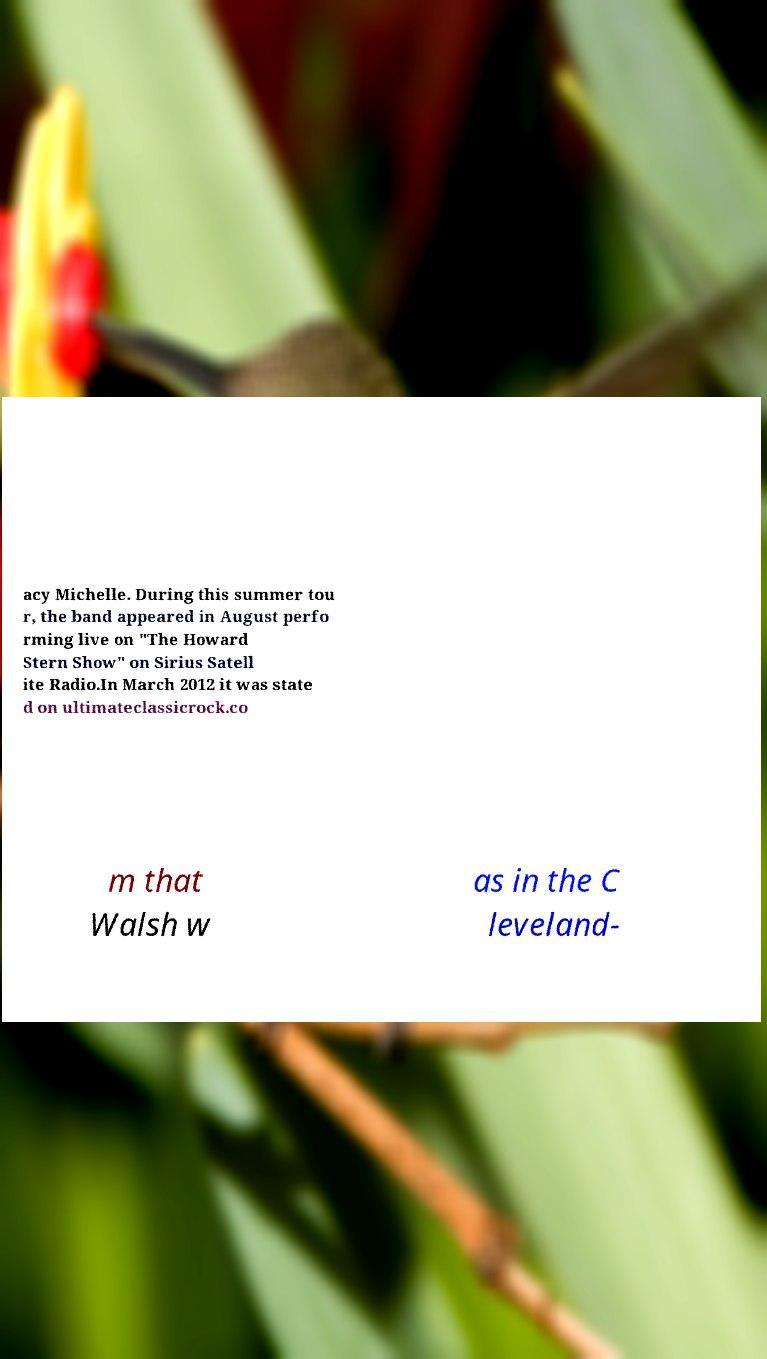There's text embedded in this image that I need extracted. Can you transcribe it verbatim? acy Michelle. During this summer tou r, the band appeared in August perfo rming live on "The Howard Stern Show" on Sirius Satell ite Radio.In March 2012 it was state d on ultimateclassicrock.co m that Walsh w as in the C leveland- 